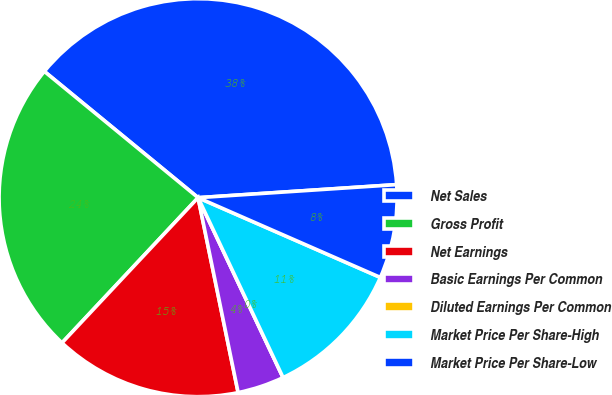<chart> <loc_0><loc_0><loc_500><loc_500><pie_chart><fcel>Net Sales<fcel>Gross Profit<fcel>Net Earnings<fcel>Basic Earnings Per Common<fcel>Diluted Earnings Per Common<fcel>Market Price Per Share-High<fcel>Market Price Per Share-Low<nl><fcel>38.01%<fcel>23.96%<fcel>15.21%<fcel>3.8%<fcel>0.0%<fcel>11.41%<fcel>7.61%<nl></chart> 